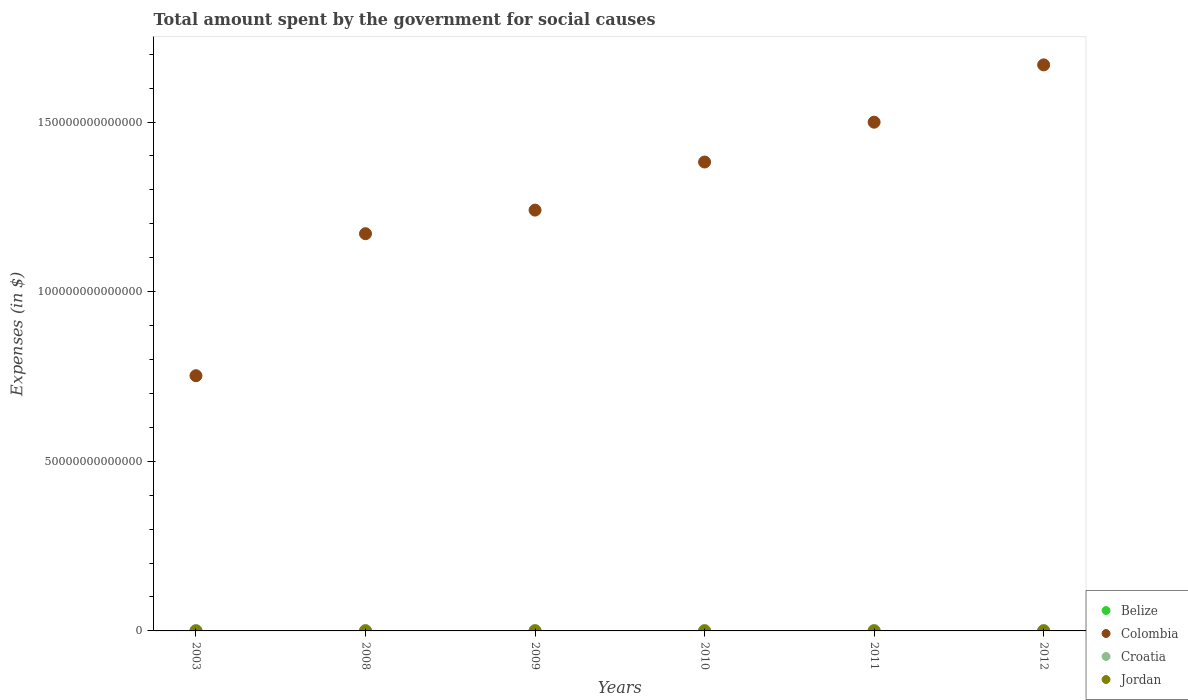What is the amount spent for social causes by the government in Jordan in 2012?
Keep it short and to the point. 6.49e+09. Across all years, what is the maximum amount spent for social causes by the government in Croatia?
Ensure brevity in your answer.  1.23e+11. Across all years, what is the minimum amount spent for social causes by the government in Jordan?
Make the answer very short. 2.13e+09. What is the total amount spent for social causes by the government in Jordan in the graph?
Provide a short and direct response. 2.91e+1. What is the difference between the amount spent for social causes by the government in Croatia in 2003 and that in 2011?
Your response must be concise. -4.17e+1. What is the difference between the amount spent for social causes by the government in Belize in 2009 and the amount spent for social causes by the government in Jordan in 2010?
Keep it short and to the point. -4.07e+09. What is the average amount spent for social causes by the government in Belize per year?
Your response must be concise. 6.56e+08. In the year 2009, what is the difference between the amount spent for social causes by the government in Jordan and amount spent for social causes by the government in Belize?
Give a very brief answer. 4.42e+09. In how many years, is the amount spent for social causes by the government in Colombia greater than 40000000000000 $?
Provide a short and direct response. 6. What is the ratio of the amount spent for social causes by the government in Belize in 2011 to that in 2012?
Provide a succinct answer. 1.04. Is the amount spent for social causes by the government in Croatia in 2003 less than that in 2010?
Keep it short and to the point. Yes. Is the difference between the amount spent for social causes by the government in Jordan in 2003 and 2009 greater than the difference between the amount spent for social causes by the government in Belize in 2003 and 2009?
Your answer should be compact. No. What is the difference between the highest and the second highest amount spent for social causes by the government in Belize?
Give a very brief answer. 2.59e+07. What is the difference between the highest and the lowest amount spent for social causes by the government in Croatia?
Ensure brevity in your answer.  4.19e+1. Is it the case that in every year, the sum of the amount spent for social causes by the government in Jordan and amount spent for social causes by the government in Croatia  is greater than the sum of amount spent for social causes by the government in Belize and amount spent for social causes by the government in Colombia?
Provide a succinct answer. Yes. Does the amount spent for social causes by the government in Croatia monotonically increase over the years?
Ensure brevity in your answer.  No. How many dotlines are there?
Ensure brevity in your answer.  4. What is the difference between two consecutive major ticks on the Y-axis?
Your answer should be very brief. 5.00e+13. Does the graph contain grids?
Make the answer very short. No. What is the title of the graph?
Provide a short and direct response. Total amount spent by the government for social causes. What is the label or title of the X-axis?
Offer a terse response. Years. What is the label or title of the Y-axis?
Offer a very short reply. Expenses (in $). What is the Expenses (in $) in Belize in 2003?
Keep it short and to the point. 4.78e+08. What is the Expenses (in $) in Colombia in 2003?
Offer a very short reply. 7.52e+13. What is the Expenses (in $) in Croatia in 2003?
Ensure brevity in your answer.  8.07e+1. What is the Expenses (in $) in Jordan in 2003?
Ensure brevity in your answer.  2.13e+09. What is the Expenses (in $) in Belize in 2008?
Provide a succinct answer. 6.37e+08. What is the Expenses (in $) in Colombia in 2008?
Keep it short and to the point. 1.17e+14. What is the Expenses (in $) of Croatia in 2008?
Offer a terse response. 1.19e+11. What is the Expenses (in $) of Jordan in 2008?
Provide a short and direct response. 4.90e+09. What is the Expenses (in $) of Belize in 2009?
Offer a terse response. 6.73e+08. What is the Expenses (in $) of Colombia in 2009?
Offer a very short reply. 1.24e+14. What is the Expenses (in $) in Croatia in 2009?
Provide a succinct answer. 1.21e+11. What is the Expenses (in $) in Jordan in 2009?
Ensure brevity in your answer.  5.09e+09. What is the Expenses (in $) of Belize in 2010?
Provide a short and direct response. 7.06e+08. What is the Expenses (in $) in Colombia in 2010?
Your response must be concise. 1.38e+14. What is the Expenses (in $) of Croatia in 2010?
Offer a terse response. 1.23e+11. What is the Expenses (in $) of Jordan in 2010?
Your answer should be compact. 4.75e+09. What is the Expenses (in $) of Belize in 2011?
Your answer should be very brief. 7.34e+08. What is the Expenses (in $) of Colombia in 2011?
Ensure brevity in your answer.  1.50e+14. What is the Expenses (in $) in Croatia in 2011?
Make the answer very short. 1.22e+11. What is the Expenses (in $) of Jordan in 2011?
Your answer should be very brief. 5.74e+09. What is the Expenses (in $) of Belize in 2012?
Keep it short and to the point. 7.08e+08. What is the Expenses (in $) in Colombia in 2012?
Provide a succinct answer. 1.67e+14. What is the Expenses (in $) in Croatia in 2012?
Give a very brief answer. 1.21e+11. What is the Expenses (in $) of Jordan in 2012?
Make the answer very short. 6.49e+09. Across all years, what is the maximum Expenses (in $) of Belize?
Your answer should be compact. 7.34e+08. Across all years, what is the maximum Expenses (in $) in Colombia?
Ensure brevity in your answer.  1.67e+14. Across all years, what is the maximum Expenses (in $) of Croatia?
Ensure brevity in your answer.  1.23e+11. Across all years, what is the maximum Expenses (in $) in Jordan?
Offer a very short reply. 6.49e+09. Across all years, what is the minimum Expenses (in $) in Belize?
Offer a very short reply. 4.78e+08. Across all years, what is the minimum Expenses (in $) in Colombia?
Give a very brief answer. 7.52e+13. Across all years, what is the minimum Expenses (in $) of Croatia?
Provide a succinct answer. 8.07e+1. Across all years, what is the minimum Expenses (in $) in Jordan?
Provide a succinct answer. 2.13e+09. What is the total Expenses (in $) in Belize in the graph?
Provide a succinct answer. 3.94e+09. What is the total Expenses (in $) in Colombia in the graph?
Ensure brevity in your answer.  7.71e+14. What is the total Expenses (in $) of Croatia in the graph?
Make the answer very short. 6.86e+11. What is the total Expenses (in $) of Jordan in the graph?
Your answer should be very brief. 2.91e+1. What is the difference between the Expenses (in $) in Belize in 2003 and that in 2008?
Offer a very short reply. -1.59e+08. What is the difference between the Expenses (in $) in Colombia in 2003 and that in 2008?
Make the answer very short. -4.19e+13. What is the difference between the Expenses (in $) in Croatia in 2003 and that in 2008?
Offer a very short reply. -3.80e+1. What is the difference between the Expenses (in $) of Jordan in 2003 and that in 2008?
Your response must be concise. -2.77e+09. What is the difference between the Expenses (in $) of Belize in 2003 and that in 2009?
Your answer should be very brief. -1.96e+08. What is the difference between the Expenses (in $) in Colombia in 2003 and that in 2009?
Make the answer very short. -4.88e+13. What is the difference between the Expenses (in $) in Croatia in 2003 and that in 2009?
Make the answer very short. -3.98e+1. What is the difference between the Expenses (in $) in Jordan in 2003 and that in 2009?
Provide a succinct answer. -2.96e+09. What is the difference between the Expenses (in $) of Belize in 2003 and that in 2010?
Ensure brevity in your answer.  -2.29e+08. What is the difference between the Expenses (in $) of Colombia in 2003 and that in 2010?
Your answer should be very brief. -6.30e+13. What is the difference between the Expenses (in $) of Croatia in 2003 and that in 2010?
Provide a short and direct response. -4.19e+1. What is the difference between the Expenses (in $) of Jordan in 2003 and that in 2010?
Offer a very short reply. -2.62e+09. What is the difference between the Expenses (in $) of Belize in 2003 and that in 2011?
Make the answer very short. -2.56e+08. What is the difference between the Expenses (in $) in Colombia in 2003 and that in 2011?
Provide a succinct answer. -7.47e+13. What is the difference between the Expenses (in $) of Croatia in 2003 and that in 2011?
Your answer should be very brief. -4.17e+1. What is the difference between the Expenses (in $) of Jordan in 2003 and that in 2011?
Provide a short and direct response. -3.61e+09. What is the difference between the Expenses (in $) in Belize in 2003 and that in 2012?
Offer a terse response. -2.30e+08. What is the difference between the Expenses (in $) in Colombia in 2003 and that in 2012?
Make the answer very short. -9.16e+13. What is the difference between the Expenses (in $) in Croatia in 2003 and that in 2012?
Your response must be concise. -4.02e+1. What is the difference between the Expenses (in $) in Jordan in 2003 and that in 2012?
Provide a short and direct response. -4.36e+09. What is the difference between the Expenses (in $) in Belize in 2008 and that in 2009?
Your response must be concise. -3.64e+07. What is the difference between the Expenses (in $) in Colombia in 2008 and that in 2009?
Make the answer very short. -6.96e+12. What is the difference between the Expenses (in $) in Croatia in 2008 and that in 2009?
Keep it short and to the point. -1.87e+09. What is the difference between the Expenses (in $) in Jordan in 2008 and that in 2009?
Offer a terse response. -1.90e+08. What is the difference between the Expenses (in $) in Belize in 2008 and that in 2010?
Offer a terse response. -6.93e+07. What is the difference between the Expenses (in $) of Colombia in 2008 and that in 2010?
Provide a short and direct response. -2.11e+13. What is the difference between the Expenses (in $) of Croatia in 2008 and that in 2010?
Give a very brief answer. -3.90e+09. What is the difference between the Expenses (in $) of Jordan in 2008 and that in 2010?
Provide a succinct answer. 1.53e+08. What is the difference between the Expenses (in $) in Belize in 2008 and that in 2011?
Ensure brevity in your answer.  -9.69e+07. What is the difference between the Expenses (in $) of Colombia in 2008 and that in 2011?
Give a very brief answer. -3.29e+13. What is the difference between the Expenses (in $) in Croatia in 2008 and that in 2011?
Keep it short and to the point. -3.74e+09. What is the difference between the Expenses (in $) of Jordan in 2008 and that in 2011?
Keep it short and to the point. -8.40e+08. What is the difference between the Expenses (in $) in Belize in 2008 and that in 2012?
Your answer should be compact. -7.10e+07. What is the difference between the Expenses (in $) in Colombia in 2008 and that in 2012?
Make the answer very short. -4.98e+13. What is the difference between the Expenses (in $) of Croatia in 2008 and that in 2012?
Ensure brevity in your answer.  -2.24e+09. What is the difference between the Expenses (in $) in Jordan in 2008 and that in 2012?
Offer a terse response. -1.59e+09. What is the difference between the Expenses (in $) of Belize in 2009 and that in 2010?
Provide a succinct answer. -3.30e+07. What is the difference between the Expenses (in $) in Colombia in 2009 and that in 2010?
Your response must be concise. -1.42e+13. What is the difference between the Expenses (in $) in Croatia in 2009 and that in 2010?
Make the answer very short. -2.03e+09. What is the difference between the Expenses (in $) of Jordan in 2009 and that in 2010?
Your answer should be very brief. 3.43e+08. What is the difference between the Expenses (in $) in Belize in 2009 and that in 2011?
Your answer should be very brief. -6.05e+07. What is the difference between the Expenses (in $) in Colombia in 2009 and that in 2011?
Offer a very short reply. -2.59e+13. What is the difference between the Expenses (in $) of Croatia in 2009 and that in 2011?
Your answer should be very brief. -1.87e+09. What is the difference between the Expenses (in $) of Jordan in 2009 and that in 2011?
Ensure brevity in your answer.  -6.50e+08. What is the difference between the Expenses (in $) of Belize in 2009 and that in 2012?
Make the answer very short. -3.46e+07. What is the difference between the Expenses (in $) of Colombia in 2009 and that in 2012?
Keep it short and to the point. -4.28e+13. What is the difference between the Expenses (in $) in Croatia in 2009 and that in 2012?
Offer a very short reply. -3.77e+08. What is the difference between the Expenses (in $) in Jordan in 2009 and that in 2012?
Your answer should be very brief. -1.40e+09. What is the difference between the Expenses (in $) in Belize in 2010 and that in 2011?
Ensure brevity in your answer.  -2.76e+07. What is the difference between the Expenses (in $) in Colombia in 2010 and that in 2011?
Your response must be concise. -1.17e+13. What is the difference between the Expenses (in $) in Croatia in 2010 and that in 2011?
Your answer should be very brief. 1.56e+08. What is the difference between the Expenses (in $) in Jordan in 2010 and that in 2011?
Give a very brief answer. -9.93e+08. What is the difference between the Expenses (in $) in Belize in 2010 and that in 2012?
Give a very brief answer. -1.63e+06. What is the difference between the Expenses (in $) in Colombia in 2010 and that in 2012?
Provide a succinct answer. -2.86e+13. What is the difference between the Expenses (in $) in Croatia in 2010 and that in 2012?
Your response must be concise. 1.65e+09. What is the difference between the Expenses (in $) of Jordan in 2010 and that in 2012?
Keep it short and to the point. -1.74e+09. What is the difference between the Expenses (in $) in Belize in 2011 and that in 2012?
Your response must be concise. 2.59e+07. What is the difference between the Expenses (in $) of Colombia in 2011 and that in 2012?
Offer a terse response. -1.69e+13. What is the difference between the Expenses (in $) in Croatia in 2011 and that in 2012?
Your answer should be very brief. 1.50e+09. What is the difference between the Expenses (in $) in Jordan in 2011 and that in 2012?
Offer a terse response. -7.46e+08. What is the difference between the Expenses (in $) of Belize in 2003 and the Expenses (in $) of Colombia in 2008?
Your response must be concise. -1.17e+14. What is the difference between the Expenses (in $) of Belize in 2003 and the Expenses (in $) of Croatia in 2008?
Your answer should be compact. -1.18e+11. What is the difference between the Expenses (in $) of Belize in 2003 and the Expenses (in $) of Jordan in 2008?
Provide a short and direct response. -4.42e+09. What is the difference between the Expenses (in $) of Colombia in 2003 and the Expenses (in $) of Croatia in 2008?
Offer a very short reply. 7.51e+13. What is the difference between the Expenses (in $) in Colombia in 2003 and the Expenses (in $) in Jordan in 2008?
Make the answer very short. 7.52e+13. What is the difference between the Expenses (in $) of Croatia in 2003 and the Expenses (in $) of Jordan in 2008?
Provide a succinct answer. 7.58e+1. What is the difference between the Expenses (in $) in Belize in 2003 and the Expenses (in $) in Colombia in 2009?
Offer a terse response. -1.24e+14. What is the difference between the Expenses (in $) of Belize in 2003 and the Expenses (in $) of Croatia in 2009?
Your answer should be very brief. -1.20e+11. What is the difference between the Expenses (in $) in Belize in 2003 and the Expenses (in $) in Jordan in 2009?
Provide a succinct answer. -4.61e+09. What is the difference between the Expenses (in $) of Colombia in 2003 and the Expenses (in $) of Croatia in 2009?
Provide a short and direct response. 7.51e+13. What is the difference between the Expenses (in $) of Colombia in 2003 and the Expenses (in $) of Jordan in 2009?
Provide a succinct answer. 7.52e+13. What is the difference between the Expenses (in $) of Croatia in 2003 and the Expenses (in $) of Jordan in 2009?
Your answer should be compact. 7.56e+1. What is the difference between the Expenses (in $) of Belize in 2003 and the Expenses (in $) of Colombia in 2010?
Keep it short and to the point. -1.38e+14. What is the difference between the Expenses (in $) in Belize in 2003 and the Expenses (in $) in Croatia in 2010?
Your answer should be compact. -1.22e+11. What is the difference between the Expenses (in $) of Belize in 2003 and the Expenses (in $) of Jordan in 2010?
Provide a short and direct response. -4.27e+09. What is the difference between the Expenses (in $) of Colombia in 2003 and the Expenses (in $) of Croatia in 2010?
Your answer should be very brief. 7.51e+13. What is the difference between the Expenses (in $) of Colombia in 2003 and the Expenses (in $) of Jordan in 2010?
Give a very brief answer. 7.52e+13. What is the difference between the Expenses (in $) in Croatia in 2003 and the Expenses (in $) in Jordan in 2010?
Offer a terse response. 7.60e+1. What is the difference between the Expenses (in $) of Belize in 2003 and the Expenses (in $) of Colombia in 2011?
Your answer should be compact. -1.50e+14. What is the difference between the Expenses (in $) in Belize in 2003 and the Expenses (in $) in Croatia in 2011?
Your response must be concise. -1.22e+11. What is the difference between the Expenses (in $) of Belize in 2003 and the Expenses (in $) of Jordan in 2011?
Offer a very short reply. -5.26e+09. What is the difference between the Expenses (in $) of Colombia in 2003 and the Expenses (in $) of Croatia in 2011?
Make the answer very short. 7.51e+13. What is the difference between the Expenses (in $) in Colombia in 2003 and the Expenses (in $) in Jordan in 2011?
Provide a short and direct response. 7.52e+13. What is the difference between the Expenses (in $) in Croatia in 2003 and the Expenses (in $) in Jordan in 2011?
Offer a terse response. 7.50e+1. What is the difference between the Expenses (in $) of Belize in 2003 and the Expenses (in $) of Colombia in 2012?
Keep it short and to the point. -1.67e+14. What is the difference between the Expenses (in $) in Belize in 2003 and the Expenses (in $) in Croatia in 2012?
Give a very brief answer. -1.20e+11. What is the difference between the Expenses (in $) in Belize in 2003 and the Expenses (in $) in Jordan in 2012?
Offer a very short reply. -6.01e+09. What is the difference between the Expenses (in $) of Colombia in 2003 and the Expenses (in $) of Croatia in 2012?
Your response must be concise. 7.51e+13. What is the difference between the Expenses (in $) in Colombia in 2003 and the Expenses (in $) in Jordan in 2012?
Make the answer very short. 7.52e+13. What is the difference between the Expenses (in $) in Croatia in 2003 and the Expenses (in $) in Jordan in 2012?
Give a very brief answer. 7.42e+1. What is the difference between the Expenses (in $) of Belize in 2008 and the Expenses (in $) of Colombia in 2009?
Your answer should be compact. -1.24e+14. What is the difference between the Expenses (in $) of Belize in 2008 and the Expenses (in $) of Croatia in 2009?
Your response must be concise. -1.20e+11. What is the difference between the Expenses (in $) in Belize in 2008 and the Expenses (in $) in Jordan in 2009?
Provide a succinct answer. -4.45e+09. What is the difference between the Expenses (in $) in Colombia in 2008 and the Expenses (in $) in Croatia in 2009?
Your answer should be very brief. 1.17e+14. What is the difference between the Expenses (in $) of Colombia in 2008 and the Expenses (in $) of Jordan in 2009?
Your answer should be compact. 1.17e+14. What is the difference between the Expenses (in $) in Croatia in 2008 and the Expenses (in $) in Jordan in 2009?
Make the answer very short. 1.14e+11. What is the difference between the Expenses (in $) of Belize in 2008 and the Expenses (in $) of Colombia in 2010?
Provide a short and direct response. -1.38e+14. What is the difference between the Expenses (in $) in Belize in 2008 and the Expenses (in $) in Croatia in 2010?
Ensure brevity in your answer.  -1.22e+11. What is the difference between the Expenses (in $) of Belize in 2008 and the Expenses (in $) of Jordan in 2010?
Offer a terse response. -4.11e+09. What is the difference between the Expenses (in $) of Colombia in 2008 and the Expenses (in $) of Croatia in 2010?
Your answer should be compact. 1.17e+14. What is the difference between the Expenses (in $) of Colombia in 2008 and the Expenses (in $) of Jordan in 2010?
Give a very brief answer. 1.17e+14. What is the difference between the Expenses (in $) in Croatia in 2008 and the Expenses (in $) in Jordan in 2010?
Your answer should be compact. 1.14e+11. What is the difference between the Expenses (in $) of Belize in 2008 and the Expenses (in $) of Colombia in 2011?
Keep it short and to the point. -1.50e+14. What is the difference between the Expenses (in $) of Belize in 2008 and the Expenses (in $) of Croatia in 2011?
Your answer should be very brief. -1.22e+11. What is the difference between the Expenses (in $) of Belize in 2008 and the Expenses (in $) of Jordan in 2011?
Give a very brief answer. -5.10e+09. What is the difference between the Expenses (in $) in Colombia in 2008 and the Expenses (in $) in Croatia in 2011?
Offer a terse response. 1.17e+14. What is the difference between the Expenses (in $) in Colombia in 2008 and the Expenses (in $) in Jordan in 2011?
Your answer should be compact. 1.17e+14. What is the difference between the Expenses (in $) of Croatia in 2008 and the Expenses (in $) of Jordan in 2011?
Provide a succinct answer. 1.13e+11. What is the difference between the Expenses (in $) of Belize in 2008 and the Expenses (in $) of Colombia in 2012?
Offer a terse response. -1.67e+14. What is the difference between the Expenses (in $) of Belize in 2008 and the Expenses (in $) of Croatia in 2012?
Make the answer very short. -1.20e+11. What is the difference between the Expenses (in $) in Belize in 2008 and the Expenses (in $) in Jordan in 2012?
Provide a short and direct response. -5.85e+09. What is the difference between the Expenses (in $) in Colombia in 2008 and the Expenses (in $) in Croatia in 2012?
Make the answer very short. 1.17e+14. What is the difference between the Expenses (in $) in Colombia in 2008 and the Expenses (in $) in Jordan in 2012?
Your answer should be very brief. 1.17e+14. What is the difference between the Expenses (in $) in Croatia in 2008 and the Expenses (in $) in Jordan in 2012?
Make the answer very short. 1.12e+11. What is the difference between the Expenses (in $) of Belize in 2009 and the Expenses (in $) of Colombia in 2010?
Make the answer very short. -1.38e+14. What is the difference between the Expenses (in $) of Belize in 2009 and the Expenses (in $) of Croatia in 2010?
Provide a succinct answer. -1.22e+11. What is the difference between the Expenses (in $) in Belize in 2009 and the Expenses (in $) in Jordan in 2010?
Your answer should be very brief. -4.07e+09. What is the difference between the Expenses (in $) in Colombia in 2009 and the Expenses (in $) in Croatia in 2010?
Offer a terse response. 1.24e+14. What is the difference between the Expenses (in $) of Colombia in 2009 and the Expenses (in $) of Jordan in 2010?
Keep it short and to the point. 1.24e+14. What is the difference between the Expenses (in $) of Croatia in 2009 and the Expenses (in $) of Jordan in 2010?
Make the answer very short. 1.16e+11. What is the difference between the Expenses (in $) of Belize in 2009 and the Expenses (in $) of Colombia in 2011?
Your answer should be compact. -1.50e+14. What is the difference between the Expenses (in $) of Belize in 2009 and the Expenses (in $) of Croatia in 2011?
Offer a very short reply. -1.22e+11. What is the difference between the Expenses (in $) of Belize in 2009 and the Expenses (in $) of Jordan in 2011?
Offer a terse response. -5.07e+09. What is the difference between the Expenses (in $) of Colombia in 2009 and the Expenses (in $) of Croatia in 2011?
Your response must be concise. 1.24e+14. What is the difference between the Expenses (in $) in Colombia in 2009 and the Expenses (in $) in Jordan in 2011?
Ensure brevity in your answer.  1.24e+14. What is the difference between the Expenses (in $) of Croatia in 2009 and the Expenses (in $) of Jordan in 2011?
Your response must be concise. 1.15e+11. What is the difference between the Expenses (in $) in Belize in 2009 and the Expenses (in $) in Colombia in 2012?
Give a very brief answer. -1.67e+14. What is the difference between the Expenses (in $) of Belize in 2009 and the Expenses (in $) of Croatia in 2012?
Provide a short and direct response. -1.20e+11. What is the difference between the Expenses (in $) of Belize in 2009 and the Expenses (in $) of Jordan in 2012?
Give a very brief answer. -5.81e+09. What is the difference between the Expenses (in $) of Colombia in 2009 and the Expenses (in $) of Croatia in 2012?
Your answer should be very brief. 1.24e+14. What is the difference between the Expenses (in $) in Colombia in 2009 and the Expenses (in $) in Jordan in 2012?
Provide a succinct answer. 1.24e+14. What is the difference between the Expenses (in $) in Croatia in 2009 and the Expenses (in $) in Jordan in 2012?
Ensure brevity in your answer.  1.14e+11. What is the difference between the Expenses (in $) of Belize in 2010 and the Expenses (in $) of Colombia in 2011?
Make the answer very short. -1.50e+14. What is the difference between the Expenses (in $) of Belize in 2010 and the Expenses (in $) of Croatia in 2011?
Ensure brevity in your answer.  -1.22e+11. What is the difference between the Expenses (in $) of Belize in 2010 and the Expenses (in $) of Jordan in 2011?
Your answer should be compact. -5.03e+09. What is the difference between the Expenses (in $) of Colombia in 2010 and the Expenses (in $) of Croatia in 2011?
Your answer should be compact. 1.38e+14. What is the difference between the Expenses (in $) of Colombia in 2010 and the Expenses (in $) of Jordan in 2011?
Offer a terse response. 1.38e+14. What is the difference between the Expenses (in $) of Croatia in 2010 and the Expenses (in $) of Jordan in 2011?
Keep it short and to the point. 1.17e+11. What is the difference between the Expenses (in $) of Belize in 2010 and the Expenses (in $) of Colombia in 2012?
Keep it short and to the point. -1.67e+14. What is the difference between the Expenses (in $) in Belize in 2010 and the Expenses (in $) in Croatia in 2012?
Your answer should be very brief. -1.20e+11. What is the difference between the Expenses (in $) in Belize in 2010 and the Expenses (in $) in Jordan in 2012?
Your answer should be compact. -5.78e+09. What is the difference between the Expenses (in $) of Colombia in 2010 and the Expenses (in $) of Croatia in 2012?
Give a very brief answer. 1.38e+14. What is the difference between the Expenses (in $) of Colombia in 2010 and the Expenses (in $) of Jordan in 2012?
Make the answer very short. 1.38e+14. What is the difference between the Expenses (in $) of Croatia in 2010 and the Expenses (in $) of Jordan in 2012?
Your response must be concise. 1.16e+11. What is the difference between the Expenses (in $) in Belize in 2011 and the Expenses (in $) in Colombia in 2012?
Offer a very short reply. -1.67e+14. What is the difference between the Expenses (in $) in Belize in 2011 and the Expenses (in $) in Croatia in 2012?
Ensure brevity in your answer.  -1.20e+11. What is the difference between the Expenses (in $) in Belize in 2011 and the Expenses (in $) in Jordan in 2012?
Keep it short and to the point. -5.75e+09. What is the difference between the Expenses (in $) of Colombia in 2011 and the Expenses (in $) of Croatia in 2012?
Offer a very short reply. 1.50e+14. What is the difference between the Expenses (in $) of Colombia in 2011 and the Expenses (in $) of Jordan in 2012?
Your answer should be compact. 1.50e+14. What is the difference between the Expenses (in $) in Croatia in 2011 and the Expenses (in $) in Jordan in 2012?
Keep it short and to the point. 1.16e+11. What is the average Expenses (in $) of Belize per year?
Give a very brief answer. 6.56e+08. What is the average Expenses (in $) of Colombia per year?
Make the answer very short. 1.29e+14. What is the average Expenses (in $) of Croatia per year?
Offer a terse response. 1.14e+11. What is the average Expenses (in $) of Jordan per year?
Provide a short and direct response. 4.85e+09. In the year 2003, what is the difference between the Expenses (in $) in Belize and Expenses (in $) in Colombia?
Your response must be concise. -7.52e+13. In the year 2003, what is the difference between the Expenses (in $) in Belize and Expenses (in $) in Croatia?
Your answer should be very brief. -8.02e+1. In the year 2003, what is the difference between the Expenses (in $) of Belize and Expenses (in $) of Jordan?
Keep it short and to the point. -1.65e+09. In the year 2003, what is the difference between the Expenses (in $) in Colombia and Expenses (in $) in Croatia?
Make the answer very short. 7.51e+13. In the year 2003, what is the difference between the Expenses (in $) in Colombia and Expenses (in $) in Jordan?
Your response must be concise. 7.52e+13. In the year 2003, what is the difference between the Expenses (in $) in Croatia and Expenses (in $) in Jordan?
Your answer should be compact. 7.86e+1. In the year 2008, what is the difference between the Expenses (in $) of Belize and Expenses (in $) of Colombia?
Your answer should be compact. -1.17e+14. In the year 2008, what is the difference between the Expenses (in $) in Belize and Expenses (in $) in Croatia?
Your answer should be very brief. -1.18e+11. In the year 2008, what is the difference between the Expenses (in $) of Belize and Expenses (in $) of Jordan?
Give a very brief answer. -4.26e+09. In the year 2008, what is the difference between the Expenses (in $) in Colombia and Expenses (in $) in Croatia?
Your response must be concise. 1.17e+14. In the year 2008, what is the difference between the Expenses (in $) of Colombia and Expenses (in $) of Jordan?
Give a very brief answer. 1.17e+14. In the year 2008, what is the difference between the Expenses (in $) of Croatia and Expenses (in $) of Jordan?
Keep it short and to the point. 1.14e+11. In the year 2009, what is the difference between the Expenses (in $) in Belize and Expenses (in $) in Colombia?
Make the answer very short. -1.24e+14. In the year 2009, what is the difference between the Expenses (in $) in Belize and Expenses (in $) in Croatia?
Keep it short and to the point. -1.20e+11. In the year 2009, what is the difference between the Expenses (in $) in Belize and Expenses (in $) in Jordan?
Give a very brief answer. -4.42e+09. In the year 2009, what is the difference between the Expenses (in $) in Colombia and Expenses (in $) in Croatia?
Ensure brevity in your answer.  1.24e+14. In the year 2009, what is the difference between the Expenses (in $) of Colombia and Expenses (in $) of Jordan?
Keep it short and to the point. 1.24e+14. In the year 2009, what is the difference between the Expenses (in $) in Croatia and Expenses (in $) in Jordan?
Make the answer very short. 1.15e+11. In the year 2010, what is the difference between the Expenses (in $) in Belize and Expenses (in $) in Colombia?
Your response must be concise. -1.38e+14. In the year 2010, what is the difference between the Expenses (in $) of Belize and Expenses (in $) of Croatia?
Your response must be concise. -1.22e+11. In the year 2010, what is the difference between the Expenses (in $) of Belize and Expenses (in $) of Jordan?
Provide a short and direct response. -4.04e+09. In the year 2010, what is the difference between the Expenses (in $) in Colombia and Expenses (in $) in Croatia?
Offer a very short reply. 1.38e+14. In the year 2010, what is the difference between the Expenses (in $) in Colombia and Expenses (in $) in Jordan?
Provide a short and direct response. 1.38e+14. In the year 2010, what is the difference between the Expenses (in $) of Croatia and Expenses (in $) of Jordan?
Provide a succinct answer. 1.18e+11. In the year 2011, what is the difference between the Expenses (in $) of Belize and Expenses (in $) of Colombia?
Make the answer very short. -1.50e+14. In the year 2011, what is the difference between the Expenses (in $) of Belize and Expenses (in $) of Croatia?
Make the answer very short. -1.22e+11. In the year 2011, what is the difference between the Expenses (in $) of Belize and Expenses (in $) of Jordan?
Your answer should be very brief. -5.01e+09. In the year 2011, what is the difference between the Expenses (in $) in Colombia and Expenses (in $) in Croatia?
Your answer should be very brief. 1.50e+14. In the year 2011, what is the difference between the Expenses (in $) of Colombia and Expenses (in $) of Jordan?
Your response must be concise. 1.50e+14. In the year 2011, what is the difference between the Expenses (in $) in Croatia and Expenses (in $) in Jordan?
Provide a succinct answer. 1.17e+11. In the year 2012, what is the difference between the Expenses (in $) of Belize and Expenses (in $) of Colombia?
Provide a succinct answer. -1.67e+14. In the year 2012, what is the difference between the Expenses (in $) in Belize and Expenses (in $) in Croatia?
Keep it short and to the point. -1.20e+11. In the year 2012, what is the difference between the Expenses (in $) in Belize and Expenses (in $) in Jordan?
Make the answer very short. -5.78e+09. In the year 2012, what is the difference between the Expenses (in $) of Colombia and Expenses (in $) of Croatia?
Make the answer very short. 1.67e+14. In the year 2012, what is the difference between the Expenses (in $) of Colombia and Expenses (in $) of Jordan?
Your response must be concise. 1.67e+14. In the year 2012, what is the difference between the Expenses (in $) in Croatia and Expenses (in $) in Jordan?
Your answer should be compact. 1.14e+11. What is the ratio of the Expenses (in $) of Belize in 2003 to that in 2008?
Your response must be concise. 0.75. What is the ratio of the Expenses (in $) of Colombia in 2003 to that in 2008?
Provide a succinct answer. 0.64. What is the ratio of the Expenses (in $) in Croatia in 2003 to that in 2008?
Give a very brief answer. 0.68. What is the ratio of the Expenses (in $) of Jordan in 2003 to that in 2008?
Offer a terse response. 0.43. What is the ratio of the Expenses (in $) of Belize in 2003 to that in 2009?
Your answer should be compact. 0.71. What is the ratio of the Expenses (in $) of Colombia in 2003 to that in 2009?
Provide a short and direct response. 0.61. What is the ratio of the Expenses (in $) of Croatia in 2003 to that in 2009?
Provide a short and direct response. 0.67. What is the ratio of the Expenses (in $) in Jordan in 2003 to that in 2009?
Give a very brief answer. 0.42. What is the ratio of the Expenses (in $) of Belize in 2003 to that in 2010?
Make the answer very short. 0.68. What is the ratio of the Expenses (in $) of Colombia in 2003 to that in 2010?
Keep it short and to the point. 0.54. What is the ratio of the Expenses (in $) of Croatia in 2003 to that in 2010?
Your response must be concise. 0.66. What is the ratio of the Expenses (in $) in Jordan in 2003 to that in 2010?
Offer a very short reply. 0.45. What is the ratio of the Expenses (in $) of Belize in 2003 to that in 2011?
Give a very brief answer. 0.65. What is the ratio of the Expenses (in $) of Colombia in 2003 to that in 2011?
Offer a terse response. 0.5. What is the ratio of the Expenses (in $) in Croatia in 2003 to that in 2011?
Your answer should be compact. 0.66. What is the ratio of the Expenses (in $) of Jordan in 2003 to that in 2011?
Offer a very short reply. 0.37. What is the ratio of the Expenses (in $) in Belize in 2003 to that in 2012?
Provide a succinct answer. 0.67. What is the ratio of the Expenses (in $) of Colombia in 2003 to that in 2012?
Offer a very short reply. 0.45. What is the ratio of the Expenses (in $) of Croatia in 2003 to that in 2012?
Ensure brevity in your answer.  0.67. What is the ratio of the Expenses (in $) in Jordan in 2003 to that in 2012?
Offer a very short reply. 0.33. What is the ratio of the Expenses (in $) of Belize in 2008 to that in 2009?
Provide a succinct answer. 0.95. What is the ratio of the Expenses (in $) in Colombia in 2008 to that in 2009?
Provide a short and direct response. 0.94. What is the ratio of the Expenses (in $) of Croatia in 2008 to that in 2009?
Keep it short and to the point. 0.98. What is the ratio of the Expenses (in $) of Jordan in 2008 to that in 2009?
Offer a very short reply. 0.96. What is the ratio of the Expenses (in $) in Belize in 2008 to that in 2010?
Provide a short and direct response. 0.9. What is the ratio of the Expenses (in $) of Colombia in 2008 to that in 2010?
Make the answer very short. 0.85. What is the ratio of the Expenses (in $) of Croatia in 2008 to that in 2010?
Your answer should be very brief. 0.97. What is the ratio of the Expenses (in $) of Jordan in 2008 to that in 2010?
Make the answer very short. 1.03. What is the ratio of the Expenses (in $) of Belize in 2008 to that in 2011?
Your answer should be compact. 0.87. What is the ratio of the Expenses (in $) of Colombia in 2008 to that in 2011?
Your response must be concise. 0.78. What is the ratio of the Expenses (in $) of Croatia in 2008 to that in 2011?
Your response must be concise. 0.97. What is the ratio of the Expenses (in $) in Jordan in 2008 to that in 2011?
Make the answer very short. 0.85. What is the ratio of the Expenses (in $) of Belize in 2008 to that in 2012?
Ensure brevity in your answer.  0.9. What is the ratio of the Expenses (in $) of Colombia in 2008 to that in 2012?
Your answer should be very brief. 0.7. What is the ratio of the Expenses (in $) of Croatia in 2008 to that in 2012?
Offer a very short reply. 0.98. What is the ratio of the Expenses (in $) in Jordan in 2008 to that in 2012?
Ensure brevity in your answer.  0.76. What is the ratio of the Expenses (in $) of Belize in 2009 to that in 2010?
Offer a terse response. 0.95. What is the ratio of the Expenses (in $) in Colombia in 2009 to that in 2010?
Your answer should be very brief. 0.9. What is the ratio of the Expenses (in $) of Croatia in 2009 to that in 2010?
Provide a succinct answer. 0.98. What is the ratio of the Expenses (in $) of Jordan in 2009 to that in 2010?
Your response must be concise. 1.07. What is the ratio of the Expenses (in $) in Belize in 2009 to that in 2011?
Keep it short and to the point. 0.92. What is the ratio of the Expenses (in $) in Colombia in 2009 to that in 2011?
Your response must be concise. 0.83. What is the ratio of the Expenses (in $) of Croatia in 2009 to that in 2011?
Keep it short and to the point. 0.98. What is the ratio of the Expenses (in $) in Jordan in 2009 to that in 2011?
Ensure brevity in your answer.  0.89. What is the ratio of the Expenses (in $) of Belize in 2009 to that in 2012?
Your answer should be very brief. 0.95. What is the ratio of the Expenses (in $) in Colombia in 2009 to that in 2012?
Your answer should be compact. 0.74. What is the ratio of the Expenses (in $) of Croatia in 2009 to that in 2012?
Give a very brief answer. 1. What is the ratio of the Expenses (in $) of Jordan in 2009 to that in 2012?
Provide a succinct answer. 0.78. What is the ratio of the Expenses (in $) of Belize in 2010 to that in 2011?
Your answer should be compact. 0.96. What is the ratio of the Expenses (in $) of Colombia in 2010 to that in 2011?
Offer a terse response. 0.92. What is the ratio of the Expenses (in $) in Croatia in 2010 to that in 2011?
Provide a succinct answer. 1. What is the ratio of the Expenses (in $) in Jordan in 2010 to that in 2011?
Your answer should be very brief. 0.83. What is the ratio of the Expenses (in $) in Colombia in 2010 to that in 2012?
Keep it short and to the point. 0.83. What is the ratio of the Expenses (in $) of Croatia in 2010 to that in 2012?
Your answer should be very brief. 1.01. What is the ratio of the Expenses (in $) in Jordan in 2010 to that in 2012?
Provide a succinct answer. 0.73. What is the ratio of the Expenses (in $) of Belize in 2011 to that in 2012?
Ensure brevity in your answer.  1.04. What is the ratio of the Expenses (in $) in Colombia in 2011 to that in 2012?
Offer a terse response. 0.9. What is the ratio of the Expenses (in $) of Croatia in 2011 to that in 2012?
Offer a terse response. 1.01. What is the ratio of the Expenses (in $) of Jordan in 2011 to that in 2012?
Provide a succinct answer. 0.89. What is the difference between the highest and the second highest Expenses (in $) of Belize?
Make the answer very short. 2.59e+07. What is the difference between the highest and the second highest Expenses (in $) in Colombia?
Offer a terse response. 1.69e+13. What is the difference between the highest and the second highest Expenses (in $) of Croatia?
Make the answer very short. 1.56e+08. What is the difference between the highest and the second highest Expenses (in $) of Jordan?
Offer a very short reply. 7.46e+08. What is the difference between the highest and the lowest Expenses (in $) in Belize?
Offer a terse response. 2.56e+08. What is the difference between the highest and the lowest Expenses (in $) of Colombia?
Provide a short and direct response. 9.16e+13. What is the difference between the highest and the lowest Expenses (in $) in Croatia?
Your response must be concise. 4.19e+1. What is the difference between the highest and the lowest Expenses (in $) of Jordan?
Offer a very short reply. 4.36e+09. 